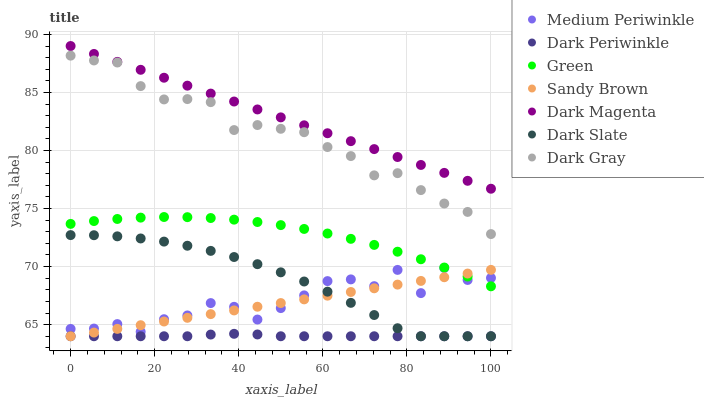Does Dark Periwinkle have the minimum area under the curve?
Answer yes or no. Yes. Does Dark Magenta have the maximum area under the curve?
Answer yes or no. Yes. Does Medium Periwinkle have the minimum area under the curve?
Answer yes or no. No. Does Medium Periwinkle have the maximum area under the curve?
Answer yes or no. No. Is Sandy Brown the smoothest?
Answer yes or no. Yes. Is Medium Periwinkle the roughest?
Answer yes or no. Yes. Is Dark Gray the smoothest?
Answer yes or no. No. Is Dark Gray the roughest?
Answer yes or no. No. Does Dark Slate have the lowest value?
Answer yes or no. Yes. Does Medium Periwinkle have the lowest value?
Answer yes or no. No. Does Dark Magenta have the highest value?
Answer yes or no. Yes. Does Medium Periwinkle have the highest value?
Answer yes or no. No. Is Dark Slate less than Green?
Answer yes or no. Yes. Is Green greater than Dark Slate?
Answer yes or no. Yes. Does Sandy Brown intersect Medium Periwinkle?
Answer yes or no. Yes. Is Sandy Brown less than Medium Periwinkle?
Answer yes or no. No. Is Sandy Brown greater than Medium Periwinkle?
Answer yes or no. No. Does Dark Slate intersect Green?
Answer yes or no. No. 